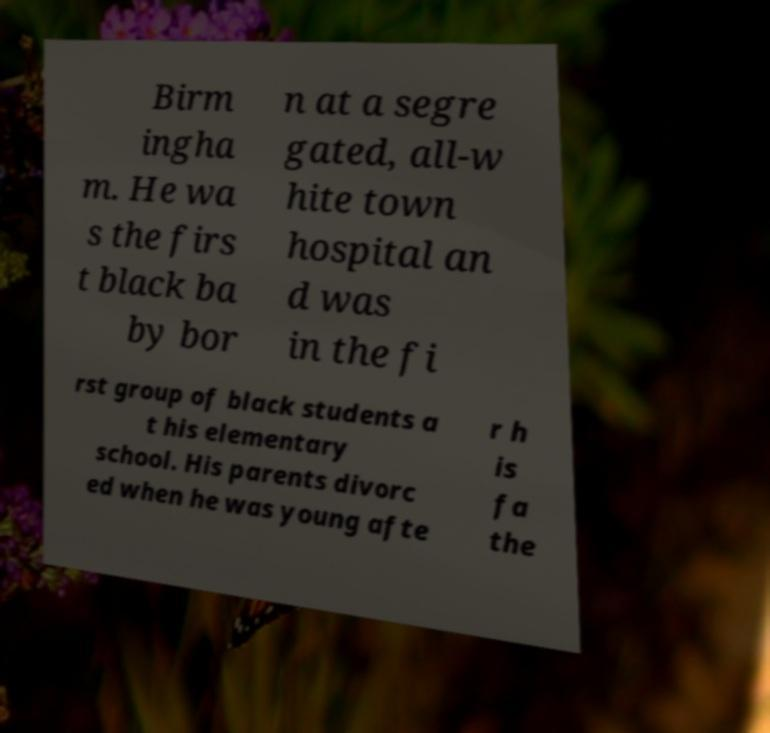What messages or text are displayed in this image? I need them in a readable, typed format. Birm ingha m. He wa s the firs t black ba by bor n at a segre gated, all-w hite town hospital an d was in the fi rst group of black students a t his elementary school. His parents divorc ed when he was young afte r h is fa the 